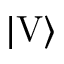Convert formula to latex. <formula><loc_0><loc_0><loc_500><loc_500>| V \rangle</formula> 